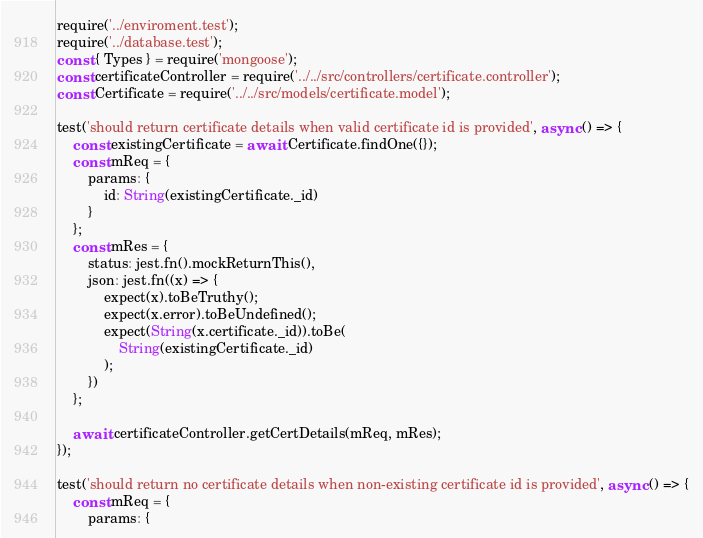Convert code to text. <code><loc_0><loc_0><loc_500><loc_500><_JavaScript_>require('../enviroment.test');
require('../database.test');
const { Types } = require('mongoose');
const certificateController = require('../../src/controllers/certificate.controller');
const Certificate = require('../../src/models/certificate.model');

test('should return certificate details when valid certificate id is provided', async () => {
    const existingCertificate = await Certificate.findOne({});
    const mReq = {
        params: {
            id: String(existingCertificate._id)
        }
    };
    const mRes = {
        status: jest.fn().mockReturnThis(),
        json: jest.fn((x) => {
            expect(x).toBeTruthy();
            expect(x.error).toBeUndefined();
            expect(String(x.certificate._id)).toBe(
                String(existingCertificate._id)
            );
        })
    };

    await certificateController.getCertDetails(mReq, mRes);
});

test('should return no certificate details when non-existing certificate id is provided', async () => {
    const mReq = {
        params: {</code> 